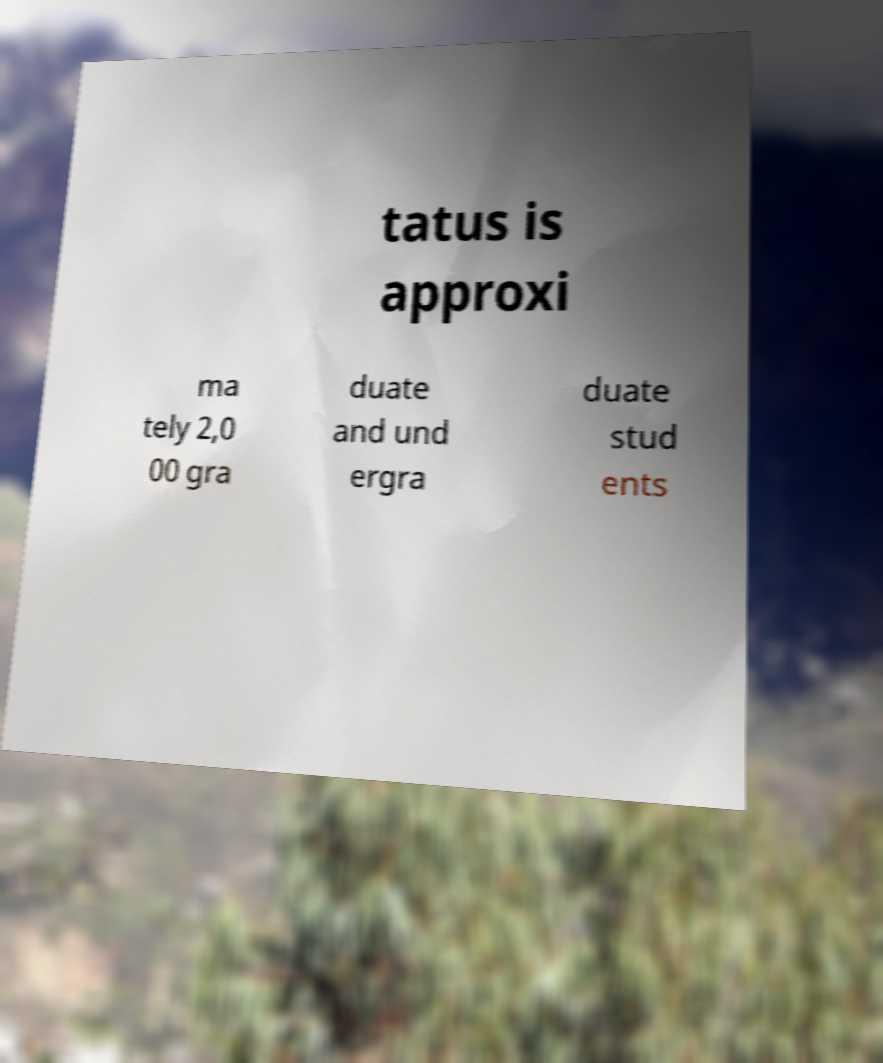Can you accurately transcribe the text from the provided image for me? tatus is approxi ma tely 2,0 00 gra duate and und ergra duate stud ents 